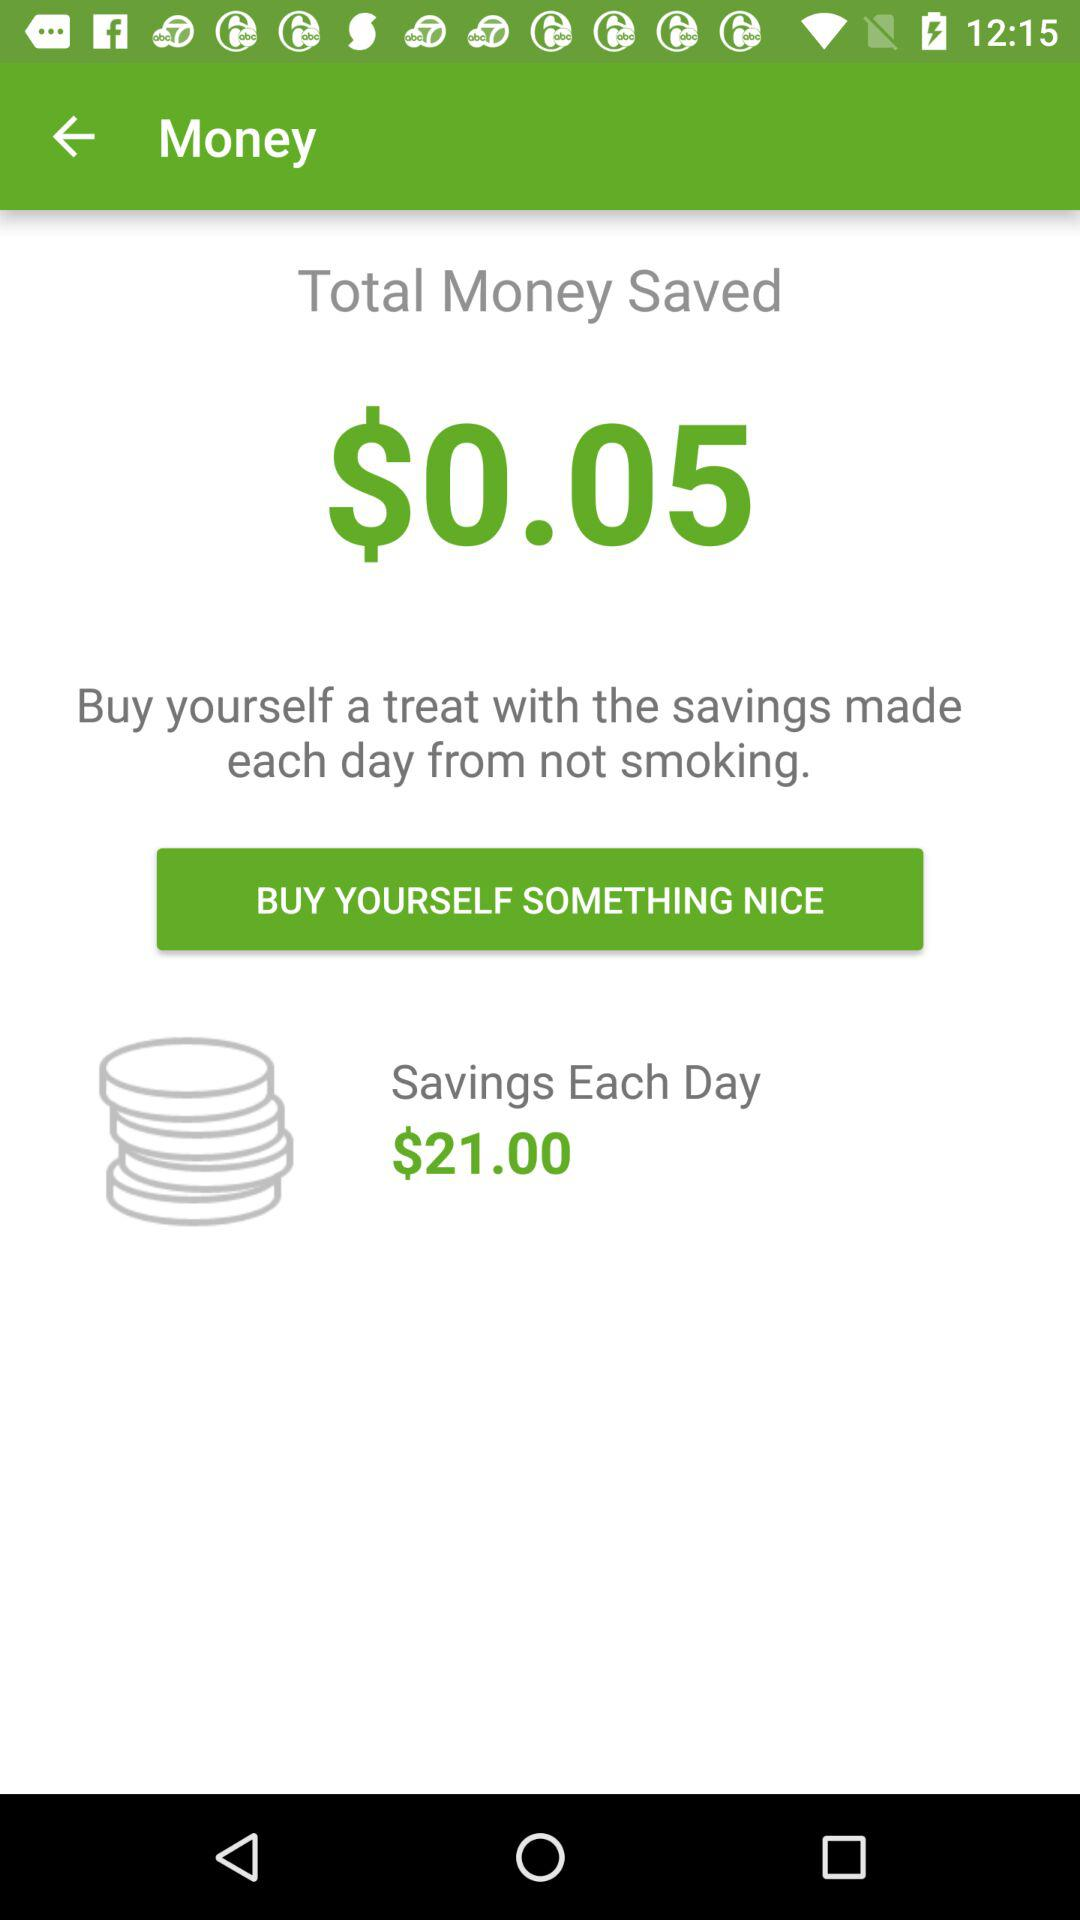What's the amount of savings each day? The amount is 21 dollars. 